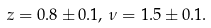<formula> <loc_0><loc_0><loc_500><loc_500>z = 0 . 8 \pm 0 . 1 , \, \nu = 1 . 5 \pm 0 . 1 .</formula> 